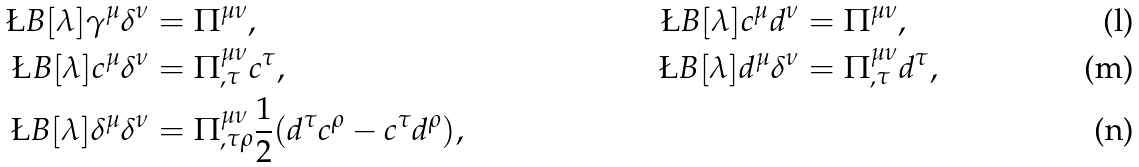Convert formula to latex. <formula><loc_0><loc_0><loc_500><loc_500>\L B [ \lambda ] { \gamma ^ { \mu } } { \delta ^ { \nu } } & = \Pi ^ { \mu \nu } , & \L B [ \lambda ] { c ^ { \mu } } { d ^ { \nu } } & = \Pi ^ { \mu \nu } , \\ \L B [ \lambda ] { c ^ { \mu } } { \delta ^ { \nu } } & = \Pi ^ { \mu \nu } _ { , \tau } c ^ { \tau } , & \L B [ \lambda ] { d ^ { \mu } } { \delta ^ { \nu } } & = \Pi ^ { \mu \nu } _ { , \tau } d ^ { \tau } , \\ \L B [ \lambda ] { \delta ^ { \mu } } { \delta ^ { \nu } } & = \Pi ^ { \mu \nu } _ { , \tau \rho } \frac { 1 } { 2 } ( d ^ { \tau } c ^ { \rho } - c ^ { \tau } d ^ { \rho } ) , &</formula> 